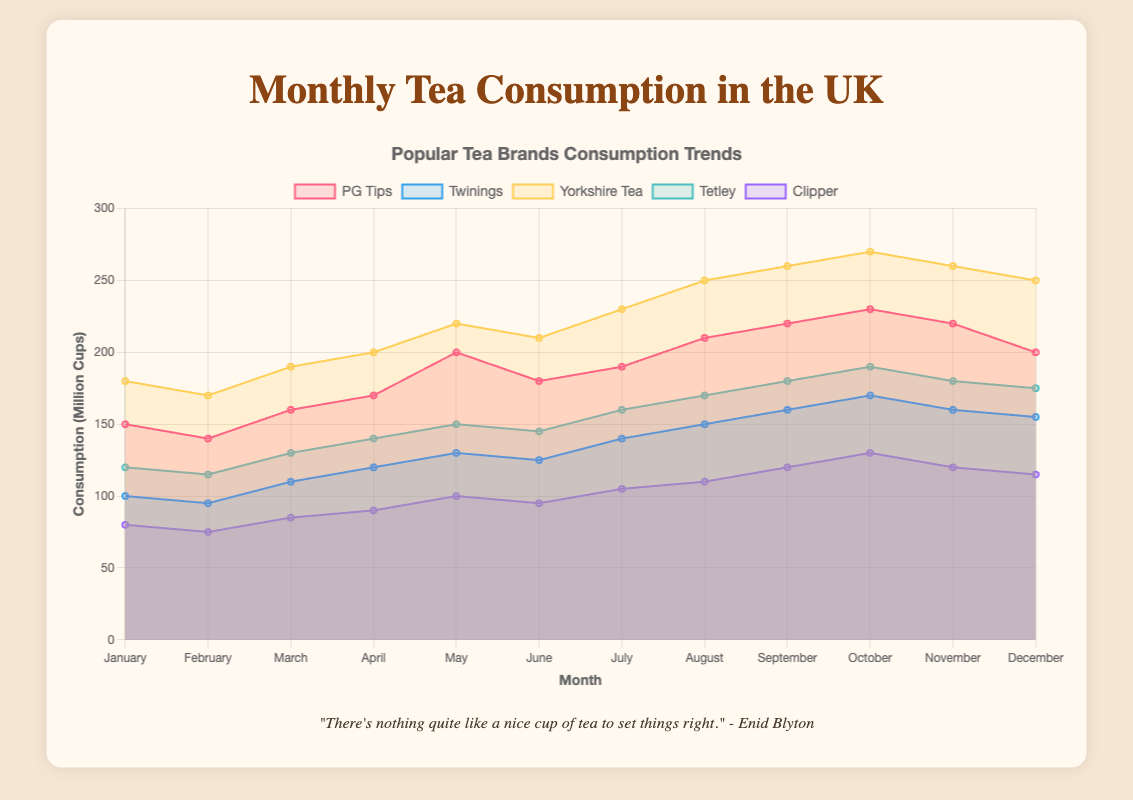What's the title of the chart? The title of the chart is usually positioned at the top and is distinctly larger and bolder than other text elements on the chart. It should summarize the key topic or data being presented, in this case: Monthly Tea Consumption in the UK.
Answer: Monthly Tea Consumption in the UK Which tea brand has the highest consumption during the month of August? To answer this, we compare the values for each tea brand in August. Look for the peak values in the August column across the different brand datasets and identify the maximum one.
Answer: Yorkshire Tea How many brands are being tracked in this chart? Count the number of different colours and data labels in the legend, which represent distinct brands. This can also be verified by the different colour-filled areas in the chart.
Answer: 5 What is the total consumption of PG Tips over the year? Add the monthly consumption values for PG Tips: 150 + 140 + 160 + 170 + 200 + 180 + 190 + 210 + 220 + 230 + 220 + 200. Sum these numbers to find the total annual consumption.
Answer: 2370 In which month does Twinings have the least consumption? Observe the line representing Twinings and locate the lowest point along the y-axis, then identify the corresponding month on the x-axis.
Answer: February Which tea brands see an increase in consumption from January to December? Compare the values for each brand from January to December. Identify the brands where the December value is higher than the January value.
Answer: All brands (PG Tips, Twinings, Yorkshire Tea, Tetley, Clipper) What is the difference in consumption between Yorkshire Tea and Clipper in September? Find the September values for both brands. Subtract the consumption value of Clipper from that of Yorkshire Tea to get the difference: 260 (Yorkshire Tea) - 120 (Clipper).
Answer: 140 What is the average monthly consumption for Tetley? Add the monthly consumption values for Tetley and then divide by the number of months (12): (120 + 115 + 130 + 140 + 150 + 145 + 160 + 170 + 180 + 190 + 180 + 175) / 12.
Answer: approx. 149.58 